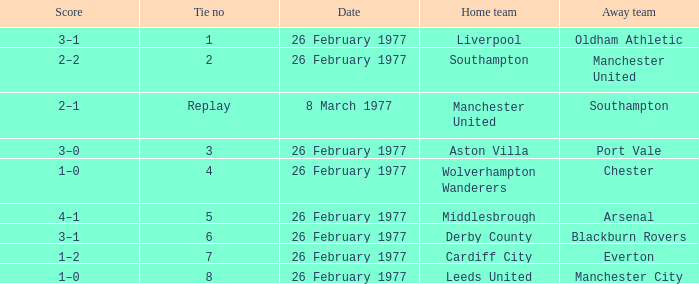Who did manchester united play against as the away team? Southampton. 